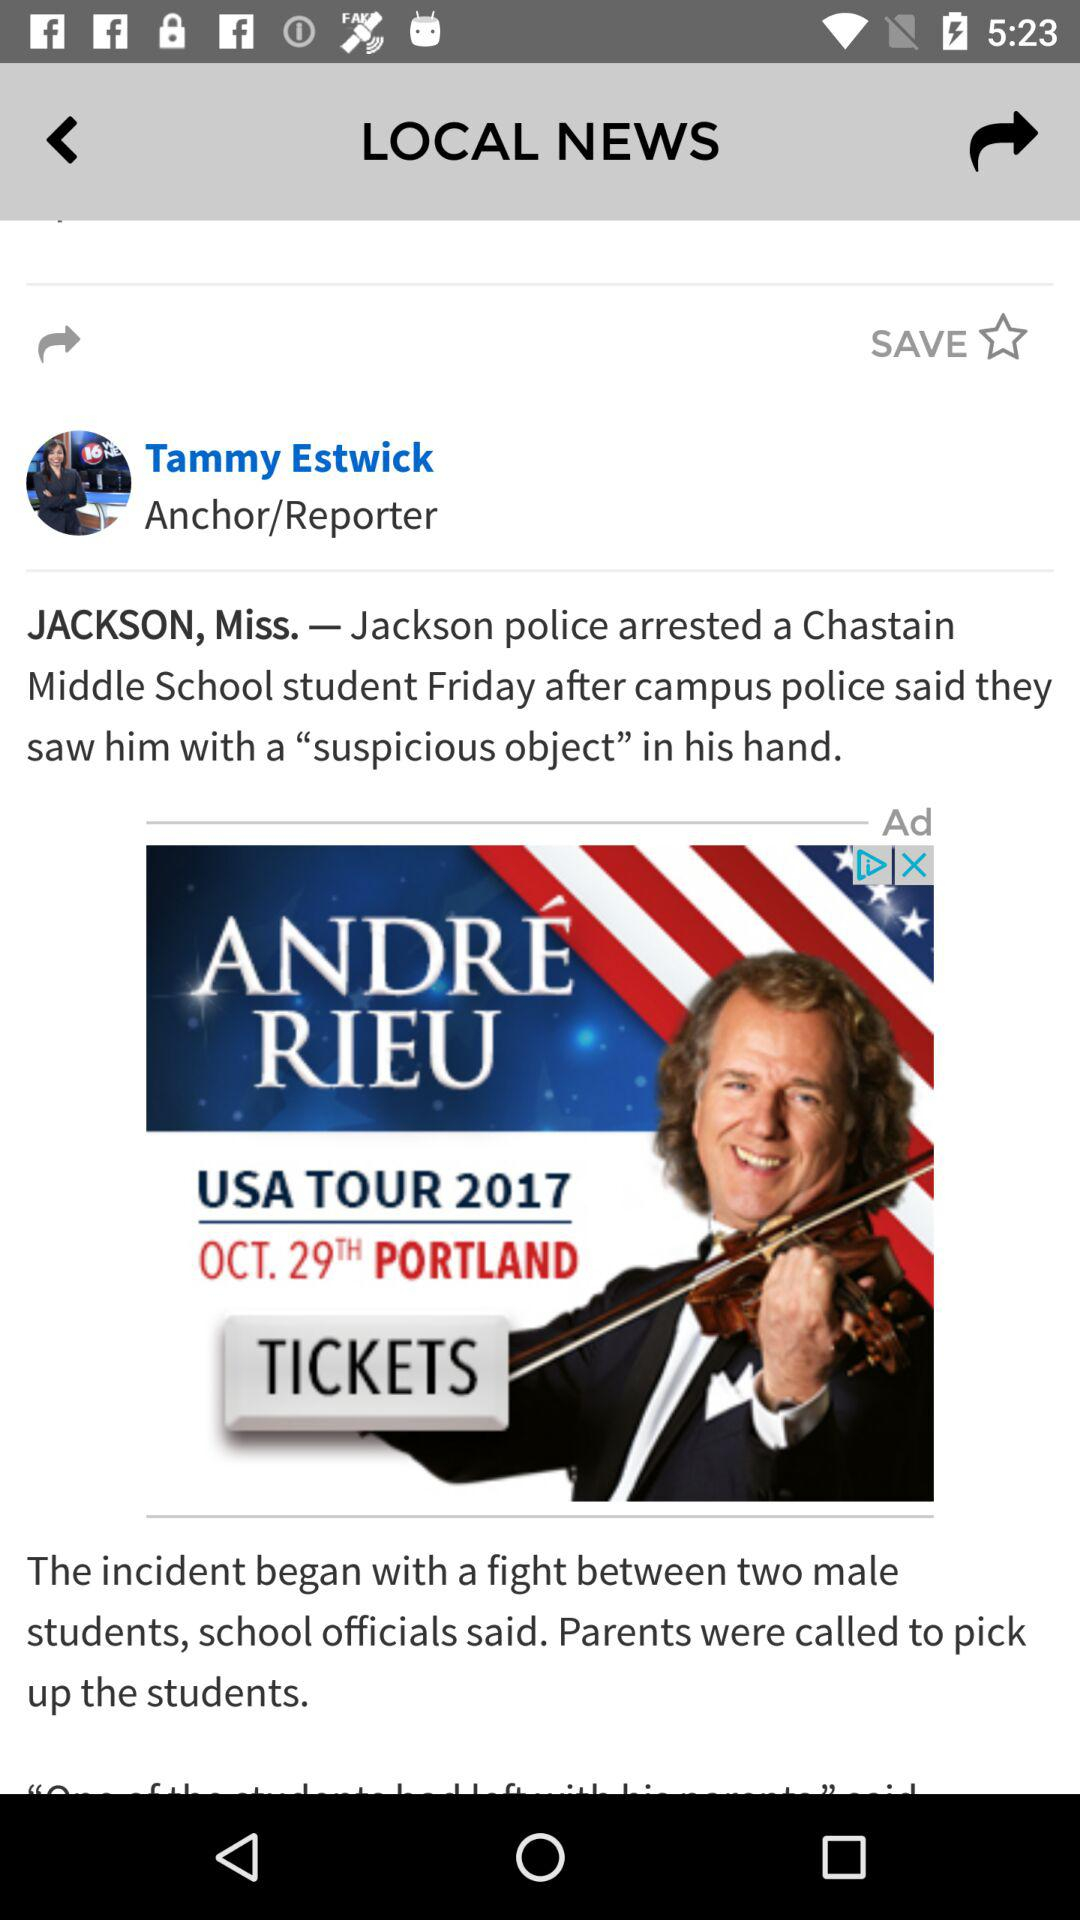What is the anchor name? The anchor name is Tammy Estwick. 